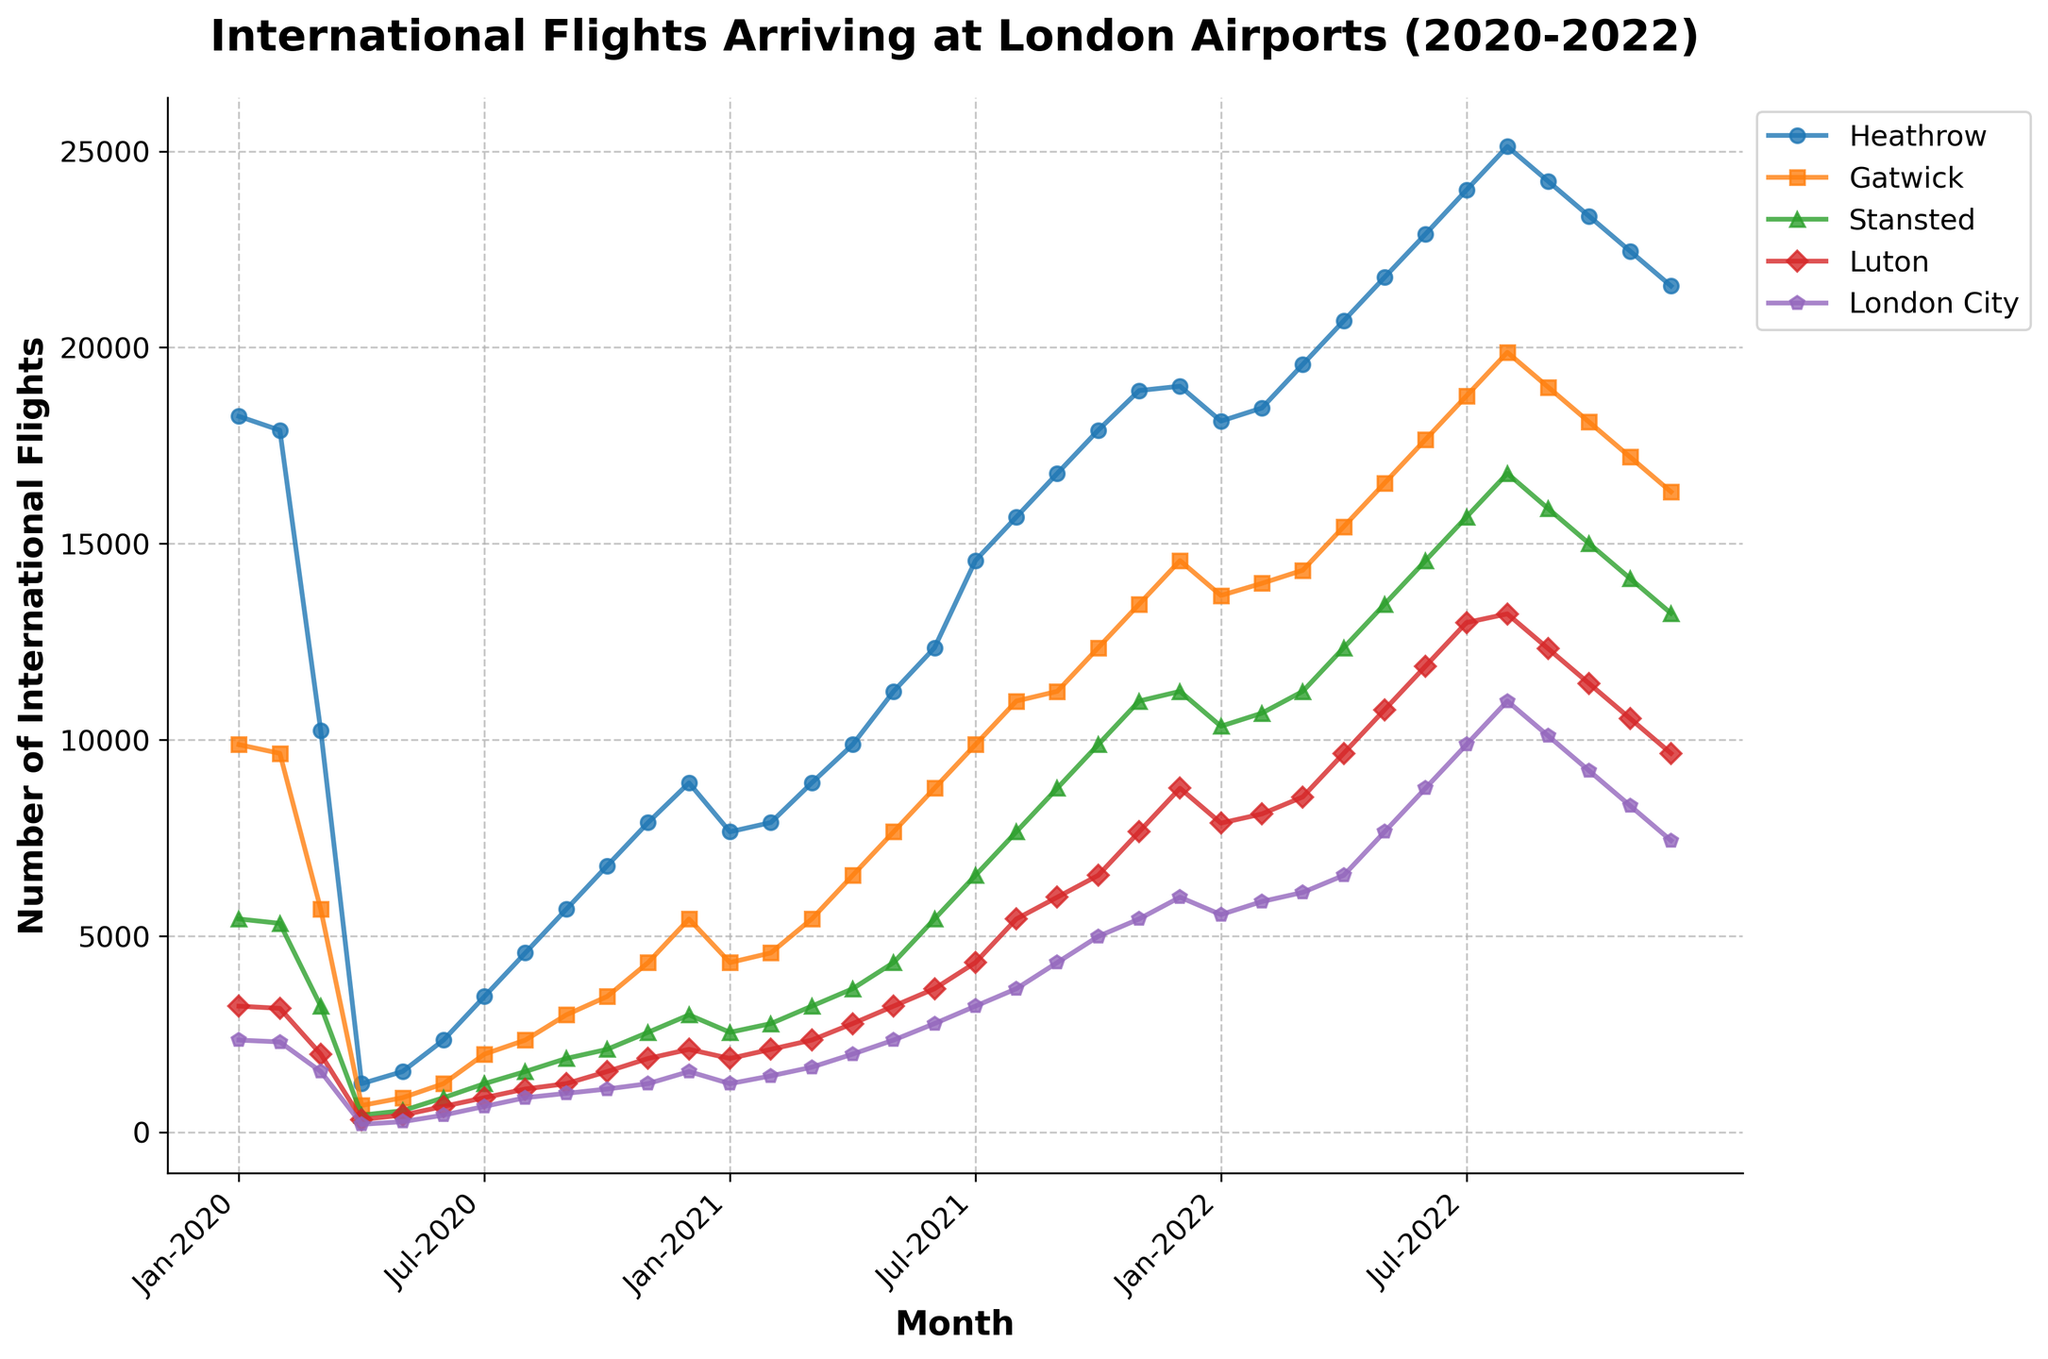Which airport had the highest number of international flights in Dec 2022? To determine which airport had the highest number of flights in Dec 2022, locate December 2022 on the x-axis, then compare the heights of the lines for each airport. Heathrow's line is the highest.
Answer: Heathrow How did the number of flights at Gatwick compare in Mar 2021 and Mar 2022? Compare the y-values for Gatwick in March 2021 and March 2022. In March 2021, Gatwick had 5432 flights; in March 2022, it had 14321 flights. Gatwick had significantly more flights in March 2022.
Answer: More in Mar 2022 Which airport showed the most consistent pattern in flight numbers from Jan 2020 to Dec 2022? To identify the most consistent pattern, look at the smoothness and less variation in the lines. London City appears to have the least fluctuation and smoothest pattern.
Answer: London City In which month and year did Stansted experience a significant increase in flights after the initial drop in 2020? Look for a steep upward slope in Stansted's line after a decrease in early 2020. This occurs in June 2020, where the number of flights increased from 432 in May 2020 to 876 in June 2020.
Answer: Jun 2020 Which two airports had a crossing point in their flight numbers between Aug 2021 and Sep 2021? Identify where two lines representing different airports intersect between these months. Heathrow and Gatwick showed crossing points.
Answer: Heathrow and Gatwick What was the approximate percentage increase in flights at Heathrow from Jan 2021 to Aug 2021? Calculate the increase ((15678 - 7654) / 7654) * 100%. From 7654 in January and 15678 in August, the percentage increase is about 104.75%.
Answer: ~104.75% During which months of 2021 did London City airport consistently rise in flight numbers? Observe London City's trend in 2021. Notice an upward trend from January to October.
Answer: Jan-Oct Which airport had the least number of flights during Apr 2020? Look at the y-values for each airport in April 2020. Heathrow recorded the least with 1234 flights.
Answer: Gatwick How does the trend of Luton compare to Stansted from Jun 2022 to Dec 2022? Compare the lines for Luton and Stansted from June to December 2022. Both show a decreasing trend, though Luton's decrease starts earlier.
Answer: Both decreasing What is the trend of international flights arriving at Heathrow from Jan 2022 to Dec 2022? Observe Heathrow's line from January to December 2022 which shows a decreasing trend.
Answer: Decreasing 